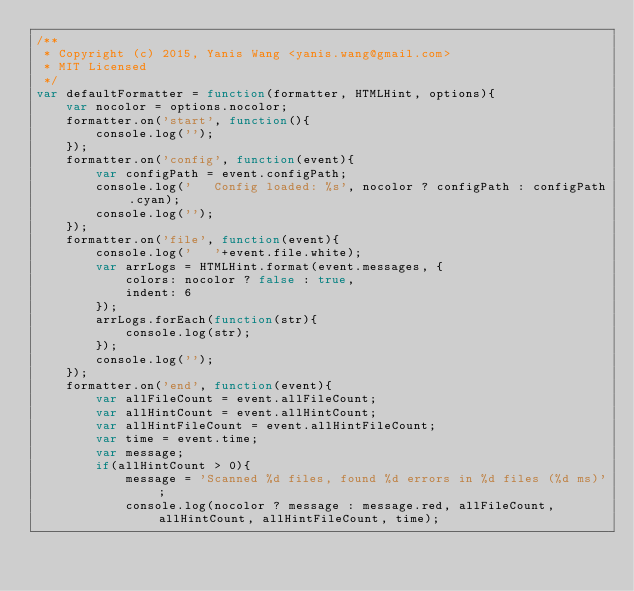<code> <loc_0><loc_0><loc_500><loc_500><_JavaScript_>/**
 * Copyright (c) 2015, Yanis Wang <yanis.wang@gmail.com>
 * MIT Licensed
 */
var defaultFormatter = function(formatter, HTMLHint, options){
    var nocolor = options.nocolor;
    formatter.on('start', function(){
        console.log('');
    });
    formatter.on('config', function(event){
        var configPath = event.configPath;
        console.log('   Config loaded: %s', nocolor ? configPath : configPath.cyan);
        console.log('');
    });
    formatter.on('file', function(event){
        console.log('   '+event.file.white);
        var arrLogs = HTMLHint.format(event.messages, {
            colors: nocolor ? false : true,
            indent: 6
        });
        arrLogs.forEach(function(str){
            console.log(str);
        });
        console.log('');
    });
    formatter.on('end', function(event){
        var allFileCount = event.allFileCount;
        var allHintCount = event.allHintCount;
        var allHintFileCount = event.allHintFileCount;
        var time = event.time;
        var message;
        if(allHintCount > 0){
            message = 'Scanned %d files, found %d errors in %d files (%d ms)';
            console.log(nocolor ? message : message.red, allFileCount, allHintCount, allHintFileCount, time);</code> 